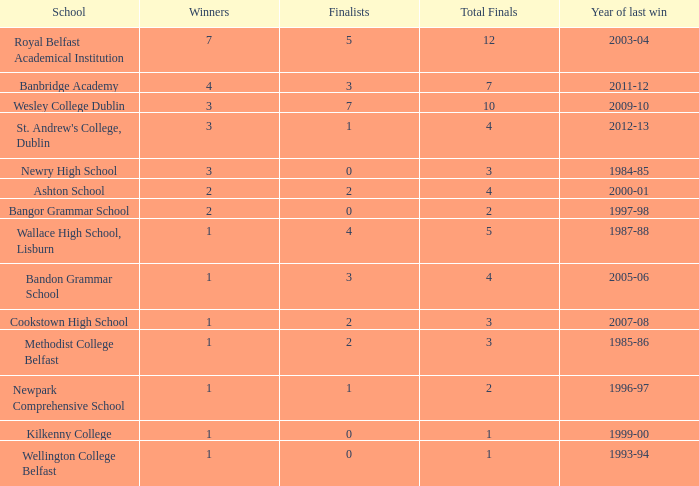What the name of  the school where the last win in 2007-08? Cookstown High School. 